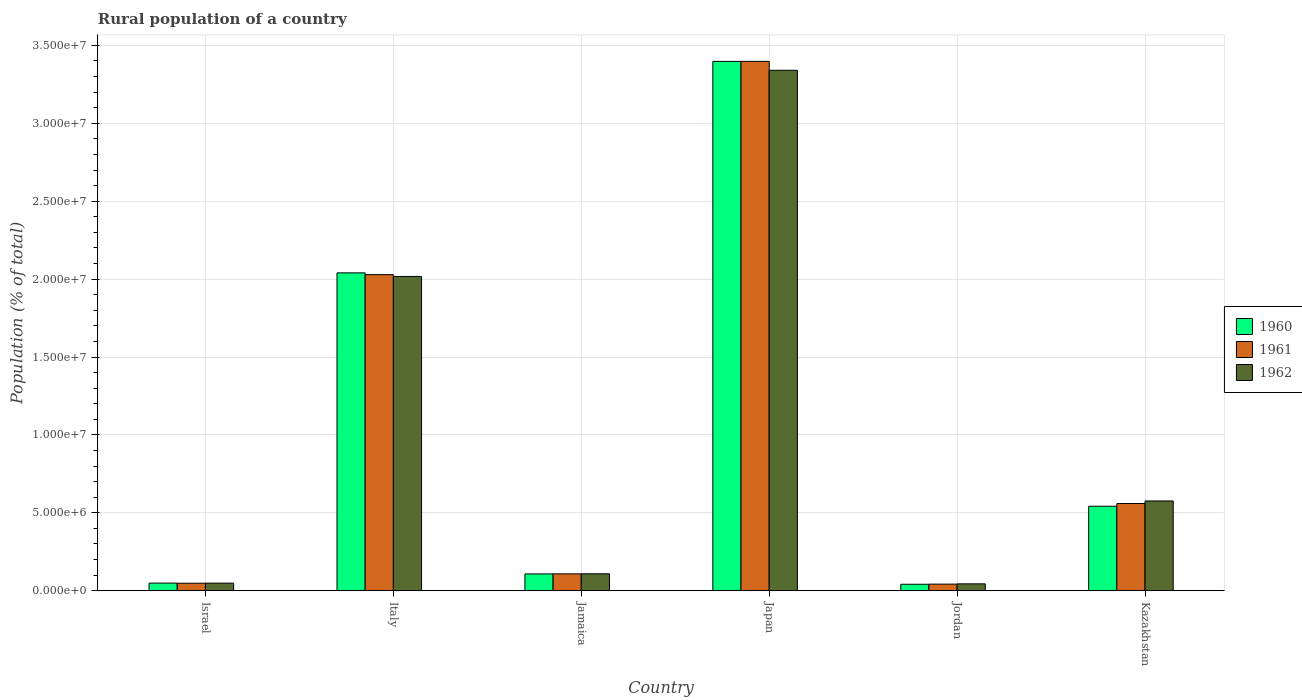How many different coloured bars are there?
Keep it short and to the point. 3. How many groups of bars are there?
Offer a very short reply. 6. Are the number of bars per tick equal to the number of legend labels?
Provide a short and direct response. Yes. Are the number of bars on each tick of the X-axis equal?
Your answer should be very brief. Yes. How many bars are there on the 3rd tick from the right?
Your answer should be compact. 3. What is the label of the 2nd group of bars from the left?
Offer a terse response. Italy. What is the rural population in 1960 in Japan?
Provide a short and direct response. 3.40e+07. Across all countries, what is the maximum rural population in 1961?
Your response must be concise. 3.40e+07. Across all countries, what is the minimum rural population in 1962?
Make the answer very short. 4.41e+05. In which country was the rural population in 1961 maximum?
Ensure brevity in your answer.  Japan. In which country was the rural population in 1962 minimum?
Your answer should be very brief. Jordan. What is the total rural population in 1962 in the graph?
Ensure brevity in your answer.  6.14e+07. What is the difference between the rural population in 1961 in Israel and that in Jamaica?
Your answer should be very brief. -6.01e+05. What is the difference between the rural population in 1961 in Jamaica and the rural population in 1962 in Israel?
Your response must be concise. 5.95e+05. What is the average rural population in 1962 per country?
Provide a short and direct response. 1.02e+07. What is the difference between the rural population of/in 1962 and rural population of/in 1961 in Japan?
Keep it short and to the point. -5.74e+05. In how many countries, is the rural population in 1961 greater than 25000000 %?
Your response must be concise. 1. What is the ratio of the rural population in 1961 in Israel to that in Italy?
Provide a succinct answer. 0.02. Is the difference between the rural population in 1962 in Italy and Kazakhstan greater than the difference between the rural population in 1961 in Italy and Kazakhstan?
Your answer should be compact. No. What is the difference between the highest and the second highest rural population in 1960?
Your answer should be very brief. -1.36e+07. What is the difference between the highest and the lowest rural population in 1960?
Your answer should be compact. 3.36e+07. Is the sum of the rural population in 1962 in Japan and Kazakhstan greater than the maximum rural population in 1961 across all countries?
Your response must be concise. Yes. What does the 2nd bar from the left in Kazakhstan represents?
Your response must be concise. 1961. What does the 1st bar from the right in Kazakhstan represents?
Ensure brevity in your answer.  1962. Is it the case that in every country, the sum of the rural population in 1961 and rural population in 1960 is greater than the rural population in 1962?
Your answer should be very brief. Yes. Are all the bars in the graph horizontal?
Your answer should be very brief. No. How many countries are there in the graph?
Provide a succinct answer. 6. Does the graph contain any zero values?
Keep it short and to the point. No. Does the graph contain grids?
Offer a terse response. Yes. Where does the legend appear in the graph?
Your response must be concise. Center right. What is the title of the graph?
Provide a short and direct response. Rural population of a country. Does "1961" appear as one of the legend labels in the graph?
Your response must be concise. Yes. What is the label or title of the Y-axis?
Offer a very short reply. Population (% of total). What is the Population (% of total) of 1960 in Israel?
Your answer should be compact. 4.89e+05. What is the Population (% of total) of 1961 in Israel?
Provide a short and direct response. 4.81e+05. What is the Population (% of total) of 1962 in Israel?
Provide a succinct answer. 4.87e+05. What is the Population (% of total) in 1960 in Italy?
Ensure brevity in your answer.  2.04e+07. What is the Population (% of total) of 1961 in Italy?
Provide a short and direct response. 2.03e+07. What is the Population (% of total) of 1962 in Italy?
Offer a terse response. 2.02e+07. What is the Population (% of total) of 1960 in Jamaica?
Your response must be concise. 1.08e+06. What is the Population (% of total) in 1961 in Jamaica?
Offer a terse response. 1.08e+06. What is the Population (% of total) in 1962 in Jamaica?
Your response must be concise. 1.09e+06. What is the Population (% of total) of 1960 in Japan?
Ensure brevity in your answer.  3.40e+07. What is the Population (% of total) of 1961 in Japan?
Keep it short and to the point. 3.40e+07. What is the Population (% of total) of 1962 in Japan?
Provide a succinct answer. 3.34e+07. What is the Population (% of total) of 1960 in Jordan?
Your response must be concise. 4.15e+05. What is the Population (% of total) in 1961 in Jordan?
Provide a short and direct response. 4.24e+05. What is the Population (% of total) in 1962 in Jordan?
Keep it short and to the point. 4.41e+05. What is the Population (% of total) in 1960 in Kazakhstan?
Give a very brief answer. 5.42e+06. What is the Population (% of total) of 1961 in Kazakhstan?
Offer a terse response. 5.60e+06. What is the Population (% of total) in 1962 in Kazakhstan?
Ensure brevity in your answer.  5.76e+06. Across all countries, what is the maximum Population (% of total) of 1960?
Ensure brevity in your answer.  3.40e+07. Across all countries, what is the maximum Population (% of total) of 1961?
Make the answer very short. 3.40e+07. Across all countries, what is the maximum Population (% of total) of 1962?
Your answer should be very brief. 3.34e+07. Across all countries, what is the minimum Population (% of total) in 1960?
Make the answer very short. 4.15e+05. Across all countries, what is the minimum Population (% of total) of 1961?
Keep it short and to the point. 4.24e+05. Across all countries, what is the minimum Population (% of total) in 1962?
Ensure brevity in your answer.  4.41e+05. What is the total Population (% of total) in 1960 in the graph?
Ensure brevity in your answer.  6.18e+07. What is the total Population (% of total) of 1961 in the graph?
Make the answer very short. 6.18e+07. What is the total Population (% of total) of 1962 in the graph?
Your response must be concise. 6.14e+07. What is the difference between the Population (% of total) of 1960 in Israel and that in Italy?
Ensure brevity in your answer.  -1.99e+07. What is the difference between the Population (% of total) in 1961 in Israel and that in Italy?
Offer a terse response. -1.98e+07. What is the difference between the Population (% of total) of 1962 in Israel and that in Italy?
Provide a short and direct response. -1.97e+07. What is the difference between the Population (% of total) in 1960 in Israel and that in Jamaica?
Give a very brief answer. -5.89e+05. What is the difference between the Population (% of total) in 1961 in Israel and that in Jamaica?
Offer a very short reply. -6.01e+05. What is the difference between the Population (% of total) of 1962 in Israel and that in Jamaica?
Provide a short and direct response. -6.00e+05. What is the difference between the Population (% of total) in 1960 in Israel and that in Japan?
Your response must be concise. -3.35e+07. What is the difference between the Population (% of total) in 1961 in Israel and that in Japan?
Your answer should be compact. -3.35e+07. What is the difference between the Population (% of total) in 1962 in Israel and that in Japan?
Keep it short and to the point. -3.29e+07. What is the difference between the Population (% of total) in 1960 in Israel and that in Jordan?
Provide a short and direct response. 7.49e+04. What is the difference between the Population (% of total) in 1961 in Israel and that in Jordan?
Offer a very short reply. 5.68e+04. What is the difference between the Population (% of total) of 1962 in Israel and that in Jordan?
Keep it short and to the point. 4.59e+04. What is the difference between the Population (% of total) in 1960 in Israel and that in Kazakhstan?
Ensure brevity in your answer.  -4.93e+06. What is the difference between the Population (% of total) of 1961 in Israel and that in Kazakhstan?
Provide a short and direct response. -5.12e+06. What is the difference between the Population (% of total) of 1962 in Israel and that in Kazakhstan?
Your response must be concise. -5.27e+06. What is the difference between the Population (% of total) of 1960 in Italy and that in Jamaica?
Provide a succinct answer. 1.93e+07. What is the difference between the Population (% of total) of 1961 in Italy and that in Jamaica?
Offer a terse response. 1.92e+07. What is the difference between the Population (% of total) of 1962 in Italy and that in Jamaica?
Give a very brief answer. 1.91e+07. What is the difference between the Population (% of total) in 1960 in Italy and that in Japan?
Make the answer very short. -1.36e+07. What is the difference between the Population (% of total) of 1961 in Italy and that in Japan?
Provide a succinct answer. -1.37e+07. What is the difference between the Population (% of total) in 1962 in Italy and that in Japan?
Offer a terse response. -1.32e+07. What is the difference between the Population (% of total) in 1960 in Italy and that in Jordan?
Your answer should be very brief. 2.00e+07. What is the difference between the Population (% of total) in 1961 in Italy and that in Jordan?
Your answer should be very brief. 1.99e+07. What is the difference between the Population (% of total) of 1962 in Italy and that in Jordan?
Keep it short and to the point. 1.97e+07. What is the difference between the Population (% of total) in 1960 in Italy and that in Kazakhstan?
Offer a terse response. 1.50e+07. What is the difference between the Population (% of total) in 1961 in Italy and that in Kazakhstan?
Provide a short and direct response. 1.47e+07. What is the difference between the Population (% of total) of 1962 in Italy and that in Kazakhstan?
Your answer should be very brief. 1.44e+07. What is the difference between the Population (% of total) of 1960 in Jamaica and that in Japan?
Ensure brevity in your answer.  -3.29e+07. What is the difference between the Population (% of total) in 1961 in Jamaica and that in Japan?
Make the answer very short. -3.29e+07. What is the difference between the Population (% of total) of 1962 in Jamaica and that in Japan?
Offer a very short reply. -3.23e+07. What is the difference between the Population (% of total) in 1960 in Jamaica and that in Jordan?
Provide a succinct answer. 6.64e+05. What is the difference between the Population (% of total) in 1961 in Jamaica and that in Jordan?
Your response must be concise. 6.58e+05. What is the difference between the Population (% of total) in 1962 in Jamaica and that in Jordan?
Give a very brief answer. 6.46e+05. What is the difference between the Population (% of total) of 1960 in Jamaica and that in Kazakhstan?
Make the answer very short. -4.34e+06. What is the difference between the Population (% of total) of 1961 in Jamaica and that in Kazakhstan?
Provide a succinct answer. -4.52e+06. What is the difference between the Population (% of total) of 1962 in Jamaica and that in Kazakhstan?
Offer a very short reply. -4.67e+06. What is the difference between the Population (% of total) of 1960 in Japan and that in Jordan?
Provide a short and direct response. 3.36e+07. What is the difference between the Population (% of total) of 1961 in Japan and that in Jordan?
Ensure brevity in your answer.  3.36e+07. What is the difference between the Population (% of total) of 1962 in Japan and that in Jordan?
Provide a short and direct response. 3.30e+07. What is the difference between the Population (% of total) in 1960 in Japan and that in Kazakhstan?
Provide a succinct answer. 2.86e+07. What is the difference between the Population (% of total) of 1961 in Japan and that in Kazakhstan?
Keep it short and to the point. 2.84e+07. What is the difference between the Population (% of total) of 1962 in Japan and that in Kazakhstan?
Provide a succinct answer. 2.76e+07. What is the difference between the Population (% of total) in 1960 in Jordan and that in Kazakhstan?
Give a very brief answer. -5.01e+06. What is the difference between the Population (% of total) of 1961 in Jordan and that in Kazakhstan?
Offer a very short reply. -5.17e+06. What is the difference between the Population (% of total) of 1962 in Jordan and that in Kazakhstan?
Your answer should be compact. -5.32e+06. What is the difference between the Population (% of total) in 1960 in Israel and the Population (% of total) in 1961 in Italy?
Give a very brief answer. -1.98e+07. What is the difference between the Population (% of total) in 1960 in Israel and the Population (% of total) in 1962 in Italy?
Ensure brevity in your answer.  -1.97e+07. What is the difference between the Population (% of total) of 1961 in Israel and the Population (% of total) of 1962 in Italy?
Keep it short and to the point. -1.97e+07. What is the difference between the Population (% of total) of 1960 in Israel and the Population (% of total) of 1961 in Jamaica?
Your response must be concise. -5.93e+05. What is the difference between the Population (% of total) of 1960 in Israel and the Population (% of total) of 1962 in Jamaica?
Keep it short and to the point. -5.98e+05. What is the difference between the Population (% of total) of 1961 in Israel and the Population (% of total) of 1962 in Jamaica?
Provide a short and direct response. -6.06e+05. What is the difference between the Population (% of total) of 1960 in Israel and the Population (% of total) of 1961 in Japan?
Offer a terse response. -3.35e+07. What is the difference between the Population (% of total) in 1960 in Israel and the Population (% of total) in 1962 in Japan?
Provide a short and direct response. -3.29e+07. What is the difference between the Population (% of total) of 1961 in Israel and the Population (% of total) of 1962 in Japan?
Ensure brevity in your answer.  -3.29e+07. What is the difference between the Population (% of total) in 1960 in Israel and the Population (% of total) in 1961 in Jordan?
Your answer should be very brief. 6.52e+04. What is the difference between the Population (% of total) of 1960 in Israel and the Population (% of total) of 1962 in Jordan?
Give a very brief answer. 4.82e+04. What is the difference between the Population (% of total) of 1961 in Israel and the Population (% of total) of 1962 in Jordan?
Give a very brief answer. 3.98e+04. What is the difference between the Population (% of total) of 1960 in Israel and the Population (% of total) of 1961 in Kazakhstan?
Provide a succinct answer. -5.11e+06. What is the difference between the Population (% of total) of 1960 in Israel and the Population (% of total) of 1962 in Kazakhstan?
Offer a terse response. -5.27e+06. What is the difference between the Population (% of total) of 1961 in Israel and the Population (% of total) of 1962 in Kazakhstan?
Ensure brevity in your answer.  -5.28e+06. What is the difference between the Population (% of total) in 1960 in Italy and the Population (% of total) in 1961 in Jamaica?
Your answer should be compact. 1.93e+07. What is the difference between the Population (% of total) in 1960 in Italy and the Population (% of total) in 1962 in Jamaica?
Your answer should be compact. 1.93e+07. What is the difference between the Population (% of total) in 1961 in Italy and the Population (% of total) in 1962 in Jamaica?
Give a very brief answer. 1.92e+07. What is the difference between the Population (% of total) in 1960 in Italy and the Population (% of total) in 1961 in Japan?
Your answer should be very brief. -1.36e+07. What is the difference between the Population (% of total) of 1960 in Italy and the Population (% of total) of 1962 in Japan?
Offer a terse response. -1.30e+07. What is the difference between the Population (% of total) in 1961 in Italy and the Population (% of total) in 1962 in Japan?
Offer a terse response. -1.31e+07. What is the difference between the Population (% of total) of 1960 in Italy and the Population (% of total) of 1961 in Jordan?
Your answer should be very brief. 2.00e+07. What is the difference between the Population (% of total) in 1960 in Italy and the Population (% of total) in 1962 in Jordan?
Make the answer very short. 2.00e+07. What is the difference between the Population (% of total) in 1961 in Italy and the Population (% of total) in 1962 in Jordan?
Make the answer very short. 1.98e+07. What is the difference between the Population (% of total) in 1960 in Italy and the Population (% of total) in 1961 in Kazakhstan?
Keep it short and to the point. 1.48e+07. What is the difference between the Population (% of total) in 1960 in Italy and the Population (% of total) in 1962 in Kazakhstan?
Give a very brief answer. 1.46e+07. What is the difference between the Population (% of total) in 1961 in Italy and the Population (% of total) in 1962 in Kazakhstan?
Ensure brevity in your answer.  1.45e+07. What is the difference between the Population (% of total) in 1960 in Jamaica and the Population (% of total) in 1961 in Japan?
Provide a short and direct response. -3.29e+07. What is the difference between the Population (% of total) of 1960 in Jamaica and the Population (% of total) of 1962 in Japan?
Provide a short and direct response. -3.23e+07. What is the difference between the Population (% of total) in 1961 in Jamaica and the Population (% of total) in 1962 in Japan?
Make the answer very short. -3.23e+07. What is the difference between the Population (% of total) in 1960 in Jamaica and the Population (% of total) in 1961 in Jordan?
Your answer should be very brief. 6.55e+05. What is the difference between the Population (% of total) of 1960 in Jamaica and the Population (% of total) of 1962 in Jordan?
Give a very brief answer. 6.38e+05. What is the difference between the Population (% of total) of 1961 in Jamaica and the Population (% of total) of 1962 in Jordan?
Your response must be concise. 6.41e+05. What is the difference between the Population (% of total) of 1960 in Jamaica and the Population (% of total) of 1961 in Kazakhstan?
Offer a terse response. -4.52e+06. What is the difference between the Population (% of total) in 1960 in Jamaica and the Population (% of total) in 1962 in Kazakhstan?
Make the answer very short. -4.68e+06. What is the difference between the Population (% of total) in 1961 in Jamaica and the Population (% of total) in 1962 in Kazakhstan?
Provide a short and direct response. -4.68e+06. What is the difference between the Population (% of total) in 1960 in Japan and the Population (% of total) in 1961 in Jordan?
Make the answer very short. 3.35e+07. What is the difference between the Population (% of total) of 1960 in Japan and the Population (% of total) of 1962 in Jordan?
Your answer should be very brief. 3.35e+07. What is the difference between the Population (% of total) of 1961 in Japan and the Population (% of total) of 1962 in Jordan?
Provide a succinct answer. 3.35e+07. What is the difference between the Population (% of total) of 1960 in Japan and the Population (% of total) of 1961 in Kazakhstan?
Offer a terse response. 2.84e+07. What is the difference between the Population (% of total) of 1960 in Japan and the Population (% of total) of 1962 in Kazakhstan?
Give a very brief answer. 2.82e+07. What is the difference between the Population (% of total) of 1961 in Japan and the Population (% of total) of 1962 in Kazakhstan?
Provide a succinct answer. 2.82e+07. What is the difference between the Population (% of total) in 1960 in Jordan and the Population (% of total) in 1961 in Kazakhstan?
Provide a succinct answer. -5.18e+06. What is the difference between the Population (% of total) in 1960 in Jordan and the Population (% of total) in 1962 in Kazakhstan?
Offer a very short reply. -5.35e+06. What is the difference between the Population (% of total) of 1961 in Jordan and the Population (% of total) of 1962 in Kazakhstan?
Your response must be concise. -5.34e+06. What is the average Population (% of total) of 1960 per country?
Make the answer very short. 1.03e+07. What is the average Population (% of total) in 1961 per country?
Your answer should be very brief. 1.03e+07. What is the average Population (% of total) of 1962 per country?
Your answer should be compact. 1.02e+07. What is the difference between the Population (% of total) of 1960 and Population (% of total) of 1961 in Israel?
Keep it short and to the point. 8410. What is the difference between the Population (% of total) of 1960 and Population (% of total) of 1962 in Israel?
Your answer should be very brief. 2267. What is the difference between the Population (% of total) of 1961 and Population (% of total) of 1962 in Israel?
Provide a succinct answer. -6143. What is the difference between the Population (% of total) in 1960 and Population (% of total) in 1961 in Italy?
Your response must be concise. 1.13e+05. What is the difference between the Population (% of total) in 1960 and Population (% of total) in 1962 in Italy?
Make the answer very short. 2.29e+05. What is the difference between the Population (% of total) in 1961 and Population (% of total) in 1962 in Italy?
Offer a very short reply. 1.16e+05. What is the difference between the Population (% of total) of 1960 and Population (% of total) of 1961 in Jamaica?
Keep it short and to the point. -3099. What is the difference between the Population (% of total) of 1960 and Population (% of total) of 1962 in Jamaica?
Make the answer very short. -8087. What is the difference between the Population (% of total) of 1961 and Population (% of total) of 1962 in Jamaica?
Make the answer very short. -4988. What is the difference between the Population (% of total) in 1960 and Population (% of total) in 1961 in Japan?
Give a very brief answer. -3641. What is the difference between the Population (% of total) of 1960 and Population (% of total) of 1962 in Japan?
Your answer should be compact. 5.70e+05. What is the difference between the Population (% of total) in 1961 and Population (% of total) in 1962 in Japan?
Ensure brevity in your answer.  5.74e+05. What is the difference between the Population (% of total) in 1960 and Population (% of total) in 1961 in Jordan?
Ensure brevity in your answer.  -9643. What is the difference between the Population (% of total) in 1960 and Population (% of total) in 1962 in Jordan?
Offer a terse response. -2.66e+04. What is the difference between the Population (% of total) in 1961 and Population (% of total) in 1962 in Jordan?
Make the answer very short. -1.70e+04. What is the difference between the Population (% of total) of 1960 and Population (% of total) of 1961 in Kazakhstan?
Provide a succinct answer. -1.76e+05. What is the difference between the Population (% of total) in 1960 and Population (% of total) in 1962 in Kazakhstan?
Your response must be concise. -3.41e+05. What is the difference between the Population (% of total) in 1961 and Population (% of total) in 1962 in Kazakhstan?
Your answer should be very brief. -1.64e+05. What is the ratio of the Population (% of total) of 1960 in Israel to that in Italy?
Give a very brief answer. 0.02. What is the ratio of the Population (% of total) of 1961 in Israel to that in Italy?
Give a very brief answer. 0.02. What is the ratio of the Population (% of total) of 1962 in Israel to that in Italy?
Make the answer very short. 0.02. What is the ratio of the Population (% of total) of 1960 in Israel to that in Jamaica?
Provide a short and direct response. 0.45. What is the ratio of the Population (% of total) in 1961 in Israel to that in Jamaica?
Provide a short and direct response. 0.44. What is the ratio of the Population (% of total) of 1962 in Israel to that in Jamaica?
Offer a terse response. 0.45. What is the ratio of the Population (% of total) in 1960 in Israel to that in Japan?
Your answer should be compact. 0.01. What is the ratio of the Population (% of total) of 1961 in Israel to that in Japan?
Provide a succinct answer. 0.01. What is the ratio of the Population (% of total) in 1962 in Israel to that in Japan?
Offer a very short reply. 0.01. What is the ratio of the Population (% of total) in 1960 in Israel to that in Jordan?
Your response must be concise. 1.18. What is the ratio of the Population (% of total) of 1961 in Israel to that in Jordan?
Offer a terse response. 1.13. What is the ratio of the Population (% of total) in 1962 in Israel to that in Jordan?
Your answer should be compact. 1.1. What is the ratio of the Population (% of total) in 1960 in Israel to that in Kazakhstan?
Your response must be concise. 0.09. What is the ratio of the Population (% of total) in 1961 in Israel to that in Kazakhstan?
Your answer should be compact. 0.09. What is the ratio of the Population (% of total) of 1962 in Israel to that in Kazakhstan?
Offer a very short reply. 0.08. What is the ratio of the Population (% of total) of 1960 in Italy to that in Jamaica?
Offer a very short reply. 18.91. What is the ratio of the Population (% of total) in 1961 in Italy to that in Jamaica?
Ensure brevity in your answer.  18.75. What is the ratio of the Population (% of total) of 1962 in Italy to that in Jamaica?
Your answer should be compact. 18.56. What is the ratio of the Population (% of total) in 1960 in Italy to that in Japan?
Provide a short and direct response. 0.6. What is the ratio of the Population (% of total) of 1961 in Italy to that in Japan?
Make the answer very short. 0.6. What is the ratio of the Population (% of total) in 1962 in Italy to that in Japan?
Ensure brevity in your answer.  0.6. What is the ratio of the Population (% of total) of 1960 in Italy to that in Jordan?
Provide a succinct answer. 49.21. What is the ratio of the Population (% of total) in 1961 in Italy to that in Jordan?
Make the answer very short. 47.82. What is the ratio of the Population (% of total) of 1962 in Italy to that in Jordan?
Your response must be concise. 45.72. What is the ratio of the Population (% of total) in 1960 in Italy to that in Kazakhstan?
Offer a very short reply. 3.76. What is the ratio of the Population (% of total) of 1961 in Italy to that in Kazakhstan?
Your answer should be compact. 3.62. What is the ratio of the Population (% of total) of 1962 in Italy to that in Kazakhstan?
Make the answer very short. 3.5. What is the ratio of the Population (% of total) in 1960 in Jamaica to that in Japan?
Offer a very short reply. 0.03. What is the ratio of the Population (% of total) of 1961 in Jamaica to that in Japan?
Make the answer very short. 0.03. What is the ratio of the Population (% of total) of 1962 in Jamaica to that in Japan?
Keep it short and to the point. 0.03. What is the ratio of the Population (% of total) in 1960 in Jamaica to that in Jordan?
Keep it short and to the point. 2.6. What is the ratio of the Population (% of total) of 1961 in Jamaica to that in Jordan?
Your answer should be compact. 2.55. What is the ratio of the Population (% of total) of 1962 in Jamaica to that in Jordan?
Give a very brief answer. 2.46. What is the ratio of the Population (% of total) in 1960 in Jamaica to that in Kazakhstan?
Provide a short and direct response. 0.2. What is the ratio of the Population (% of total) of 1961 in Jamaica to that in Kazakhstan?
Your response must be concise. 0.19. What is the ratio of the Population (% of total) of 1962 in Jamaica to that in Kazakhstan?
Provide a short and direct response. 0.19. What is the ratio of the Population (% of total) in 1960 in Japan to that in Jordan?
Your answer should be compact. 81.95. What is the ratio of the Population (% of total) in 1961 in Japan to that in Jordan?
Your response must be concise. 80.09. What is the ratio of the Population (% of total) of 1962 in Japan to that in Jordan?
Offer a very short reply. 75.71. What is the ratio of the Population (% of total) of 1960 in Japan to that in Kazakhstan?
Offer a very short reply. 6.27. What is the ratio of the Population (% of total) of 1961 in Japan to that in Kazakhstan?
Offer a terse response. 6.07. What is the ratio of the Population (% of total) of 1962 in Japan to that in Kazakhstan?
Provide a succinct answer. 5.8. What is the ratio of the Population (% of total) in 1960 in Jordan to that in Kazakhstan?
Your answer should be very brief. 0.08. What is the ratio of the Population (% of total) of 1961 in Jordan to that in Kazakhstan?
Ensure brevity in your answer.  0.08. What is the ratio of the Population (% of total) of 1962 in Jordan to that in Kazakhstan?
Offer a very short reply. 0.08. What is the difference between the highest and the second highest Population (% of total) in 1960?
Your answer should be compact. 1.36e+07. What is the difference between the highest and the second highest Population (% of total) in 1961?
Provide a succinct answer. 1.37e+07. What is the difference between the highest and the second highest Population (% of total) in 1962?
Your response must be concise. 1.32e+07. What is the difference between the highest and the lowest Population (% of total) of 1960?
Provide a succinct answer. 3.36e+07. What is the difference between the highest and the lowest Population (% of total) in 1961?
Provide a succinct answer. 3.36e+07. What is the difference between the highest and the lowest Population (% of total) of 1962?
Your answer should be compact. 3.30e+07. 